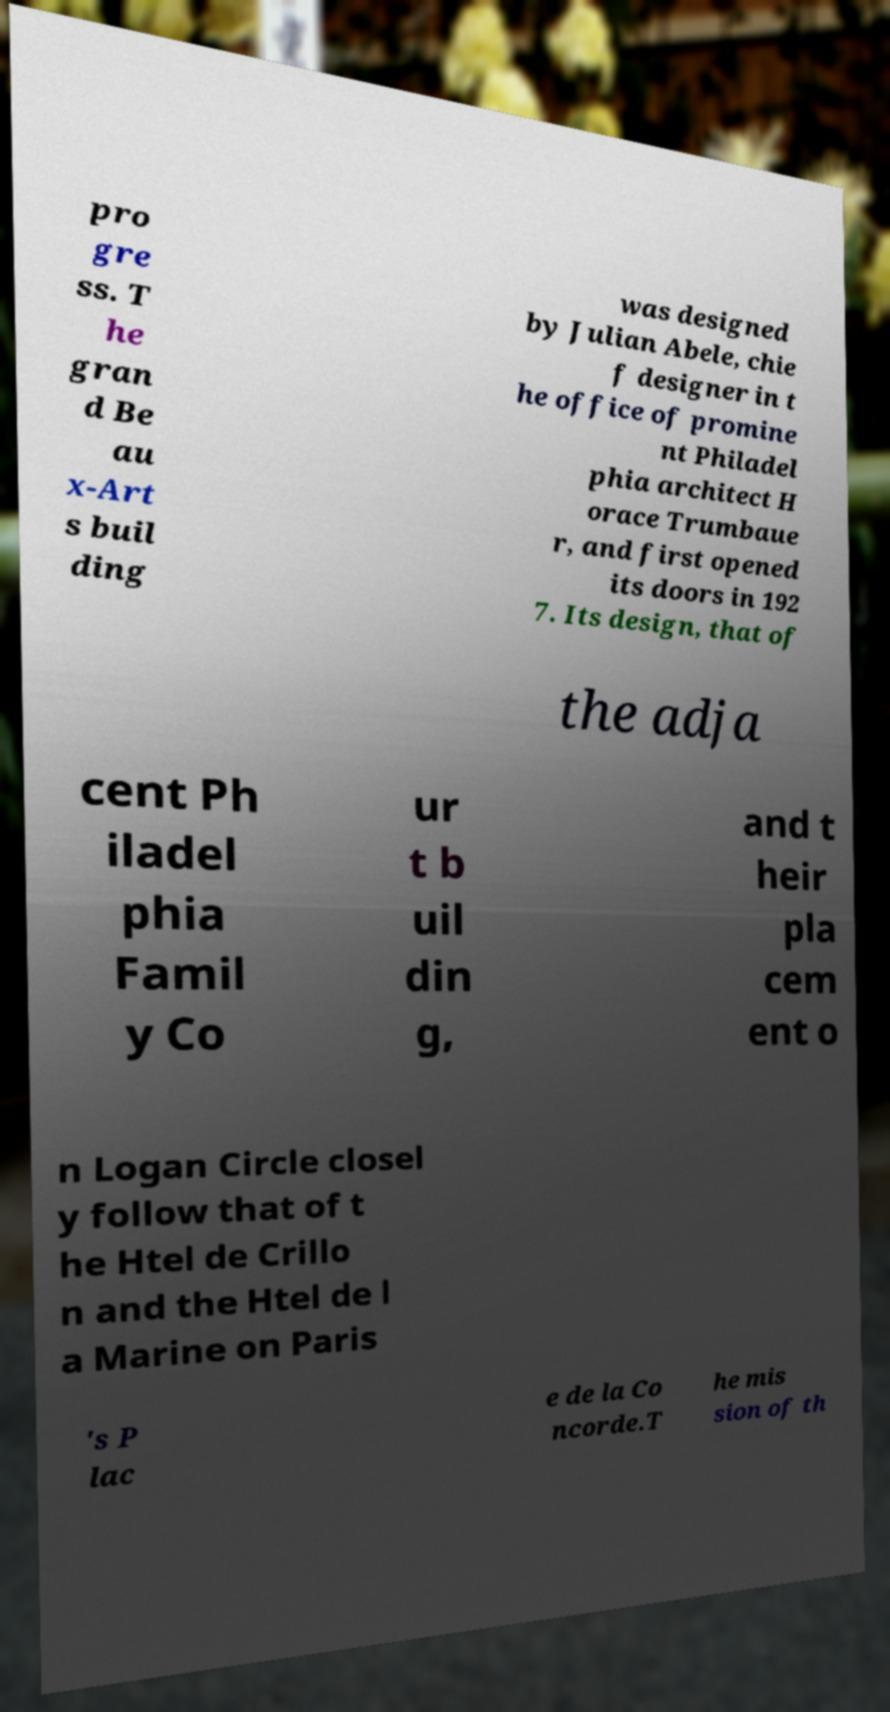Please identify and transcribe the text found in this image. pro gre ss. T he gran d Be au x-Art s buil ding was designed by Julian Abele, chie f designer in t he office of promine nt Philadel phia architect H orace Trumbaue r, and first opened its doors in 192 7. Its design, that of the adja cent Ph iladel phia Famil y Co ur t b uil din g, and t heir pla cem ent o n Logan Circle closel y follow that of t he Htel de Crillo n and the Htel de l a Marine on Paris 's P lac e de la Co ncorde.T he mis sion of th 